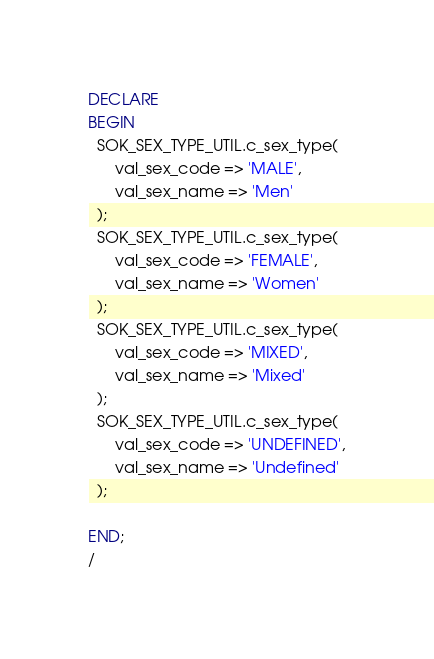Convert code to text. <code><loc_0><loc_0><loc_500><loc_500><_SQL_>DECLARE
BEGIN
  SOK_SEX_TYPE_UTIL.c_sex_type(
      val_sex_code => 'MALE',
      val_sex_name => 'Men'
  );
  SOK_SEX_TYPE_UTIL.c_sex_type(
      val_sex_code => 'FEMALE',
      val_sex_name => 'Women'
  );
  SOK_SEX_TYPE_UTIL.c_sex_type(
      val_sex_code => 'MIXED',
      val_sex_name => 'Mixed'
  );
  SOK_SEX_TYPE_UTIL.c_sex_type(
      val_sex_code => 'UNDEFINED',
      val_sex_name => 'Undefined'
  );

END;
/</code> 